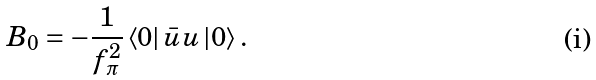Convert formula to latex. <formula><loc_0><loc_0><loc_500><loc_500>B _ { 0 } = - \frac { 1 } { f _ { \pi } ^ { 2 } } \left < 0 \right | \bar { u } u \left | 0 \right > .</formula> 